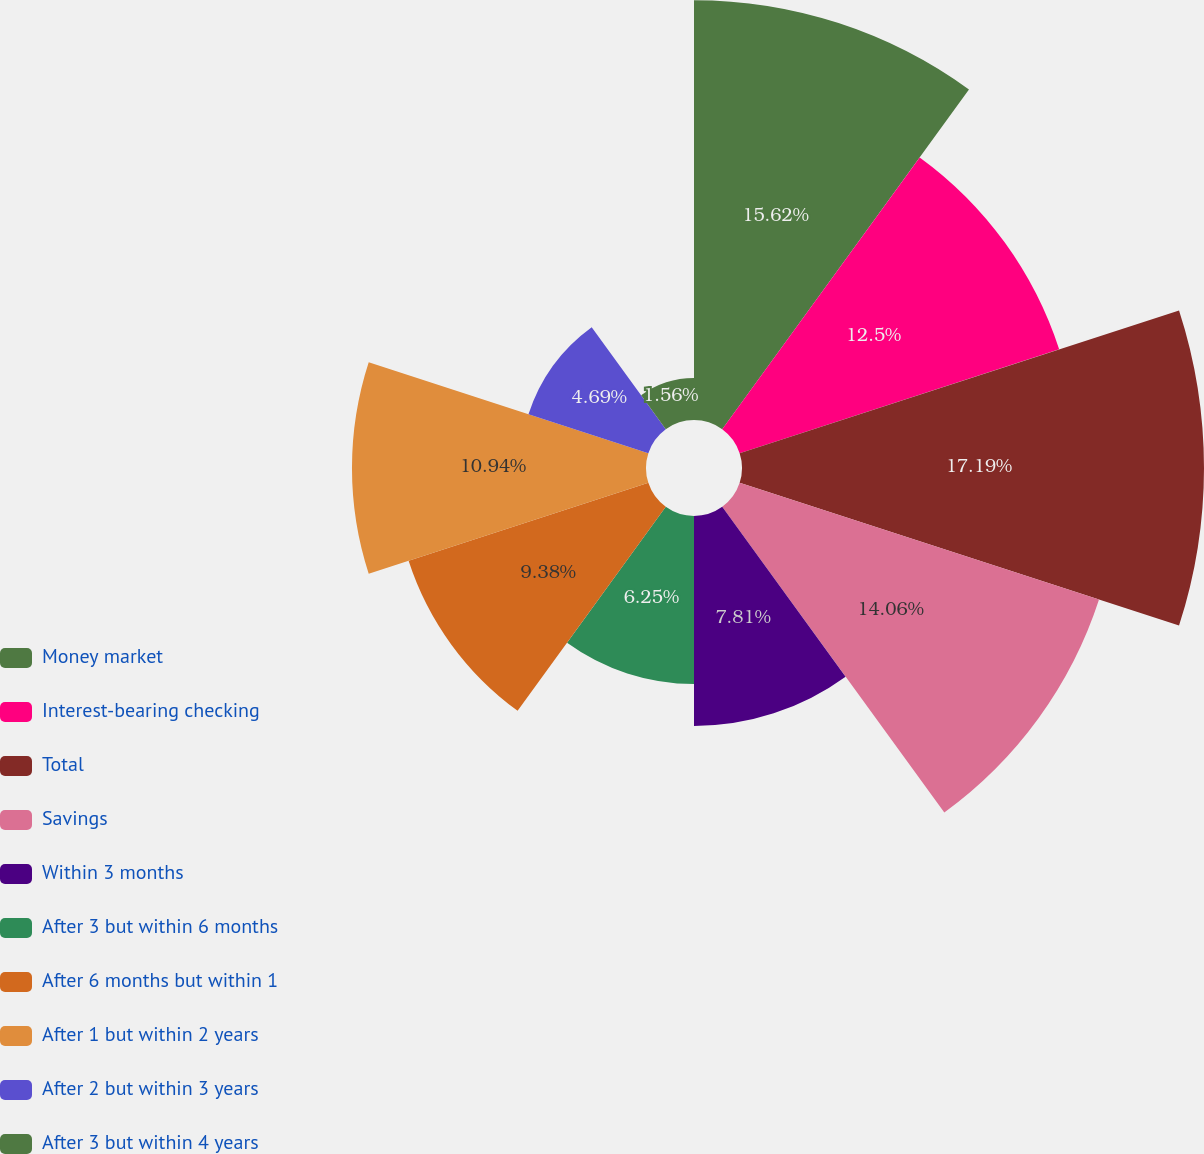<chart> <loc_0><loc_0><loc_500><loc_500><pie_chart><fcel>Money market<fcel>Interest-bearing checking<fcel>Total<fcel>Savings<fcel>Within 3 months<fcel>After 3 but within 6 months<fcel>After 6 months but within 1<fcel>After 1 but within 2 years<fcel>After 2 but within 3 years<fcel>After 3 but within 4 years<nl><fcel>15.62%<fcel>12.5%<fcel>17.19%<fcel>14.06%<fcel>7.81%<fcel>6.25%<fcel>9.38%<fcel>10.94%<fcel>4.69%<fcel>1.56%<nl></chart> 